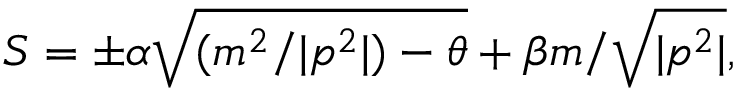<formula> <loc_0><loc_0><loc_500><loc_500>S = \pm \alpha \sqrt { ( m ^ { 2 } / | p ^ { 2 } | ) - \theta } + \beta m / \sqrt { | p ^ { 2 } | } ,</formula> 